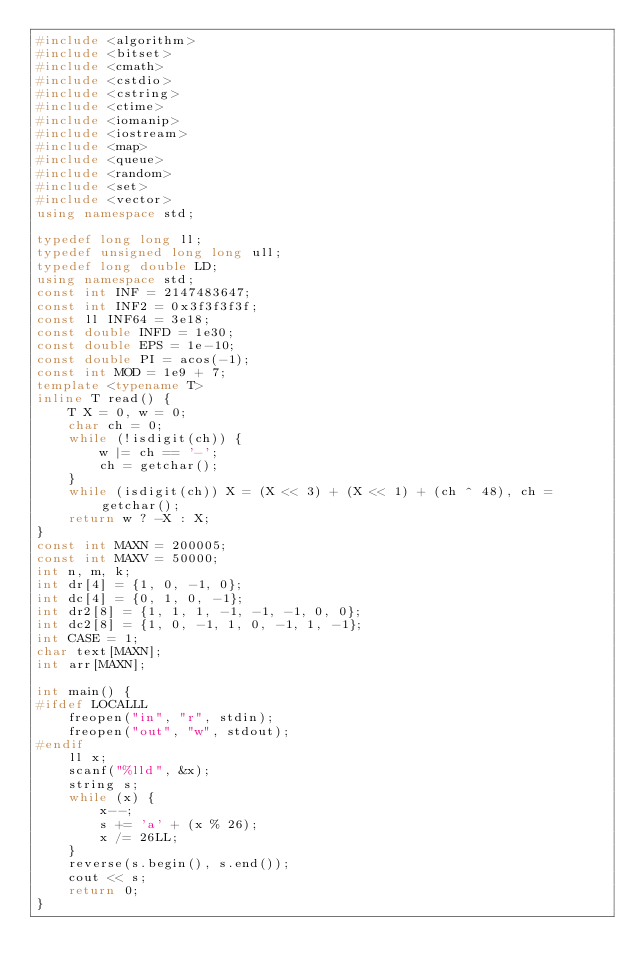Convert code to text. <code><loc_0><loc_0><loc_500><loc_500><_C++_>#include <algorithm>
#include <bitset>
#include <cmath>
#include <cstdio>
#include <cstring>
#include <ctime>
#include <iomanip>
#include <iostream>
#include <map>
#include <queue>
#include <random>
#include <set>
#include <vector>
using namespace std;

typedef long long ll;
typedef unsigned long long ull;
typedef long double LD;
using namespace std;
const int INF = 2147483647;
const int INF2 = 0x3f3f3f3f;
const ll INF64 = 3e18;
const double INFD = 1e30;
const double EPS = 1e-10;
const double PI = acos(-1);
const int MOD = 1e9 + 7;
template <typename T>
inline T read() {
    T X = 0, w = 0;
    char ch = 0;
    while (!isdigit(ch)) {
        w |= ch == '-';
        ch = getchar();
    }
    while (isdigit(ch)) X = (X << 3) + (X << 1) + (ch ^ 48), ch = getchar();
    return w ? -X : X;
}
const int MAXN = 200005;
const int MAXV = 50000;
int n, m, k;
int dr[4] = {1, 0, -1, 0};
int dc[4] = {0, 1, 0, -1};
int dr2[8] = {1, 1, 1, -1, -1, -1, 0, 0};
int dc2[8] = {1, 0, -1, 1, 0, -1, 1, -1};
int CASE = 1;
char text[MAXN];
int arr[MAXN];

int main() {
#ifdef LOCALLL
    freopen("in", "r", stdin);
    freopen("out", "w", stdout);
#endif
    ll x;
    scanf("%lld", &x);
    string s;
    while (x) {
        x--;
        s += 'a' + (x % 26);
        x /= 26LL;
    }
    reverse(s.begin(), s.end());
    cout << s;
    return 0;
}</code> 